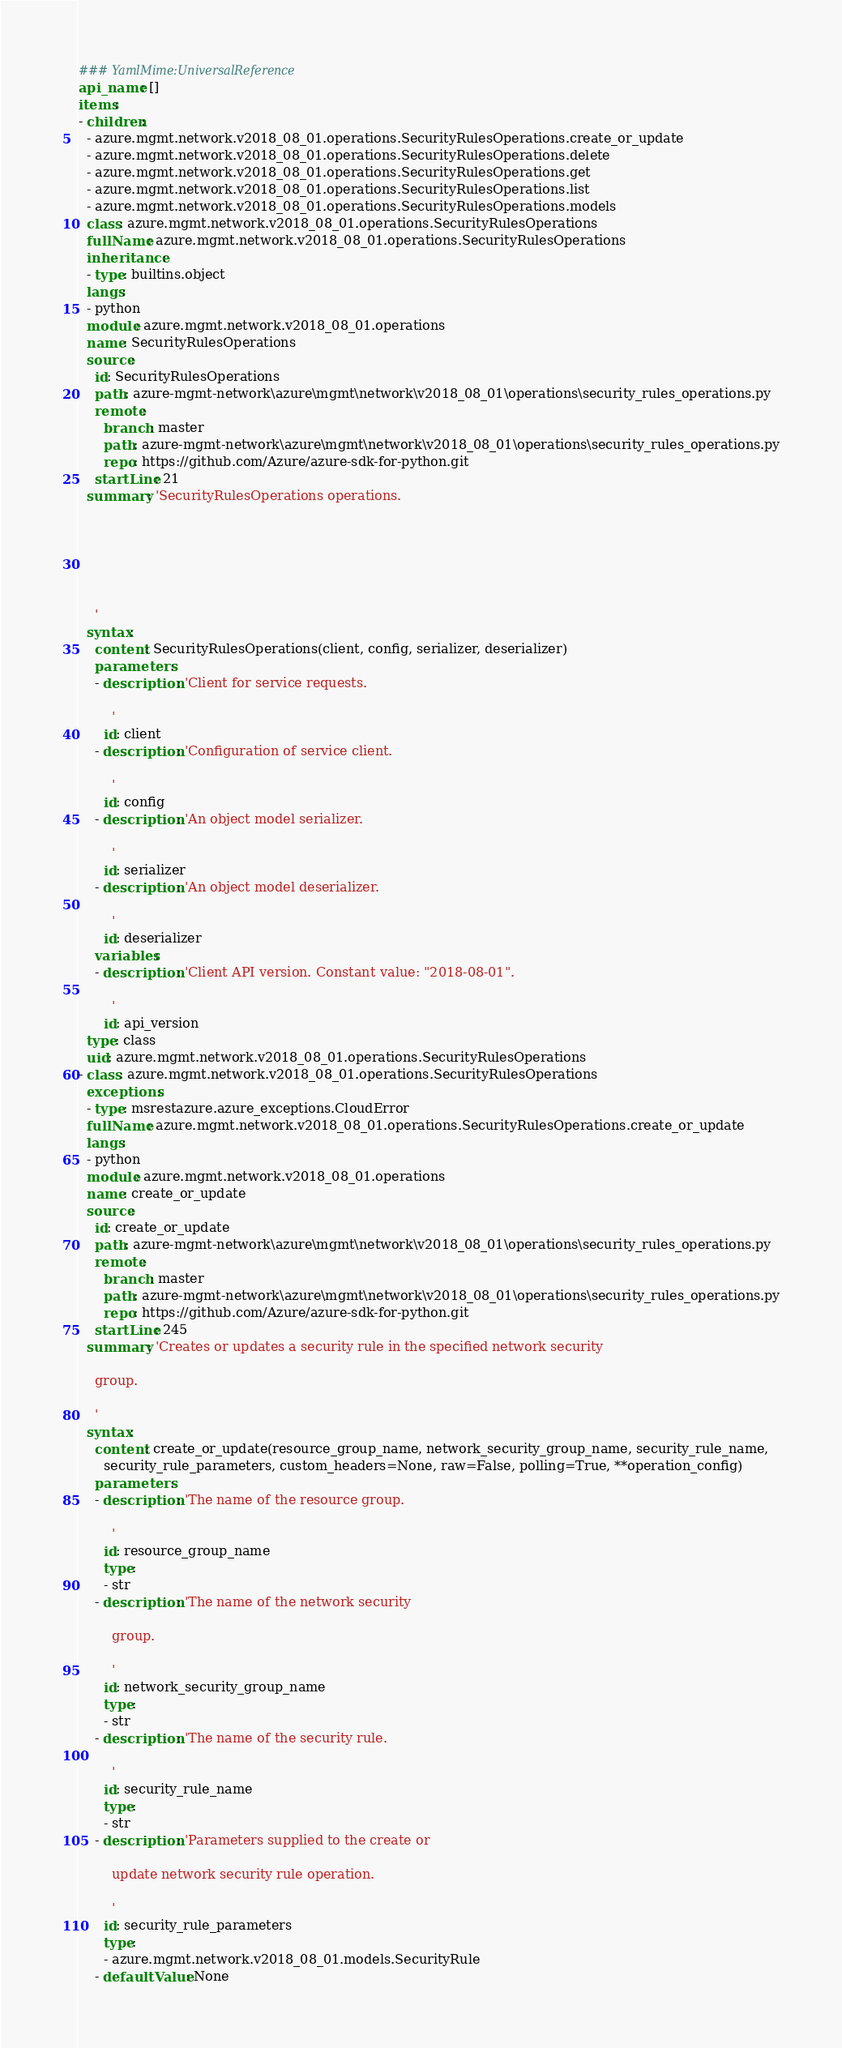<code> <loc_0><loc_0><loc_500><loc_500><_YAML_>### YamlMime:UniversalReference
api_name: []
items:
- children:
  - azure.mgmt.network.v2018_08_01.operations.SecurityRulesOperations.create_or_update
  - azure.mgmt.network.v2018_08_01.operations.SecurityRulesOperations.delete
  - azure.mgmt.network.v2018_08_01.operations.SecurityRulesOperations.get
  - azure.mgmt.network.v2018_08_01.operations.SecurityRulesOperations.list
  - azure.mgmt.network.v2018_08_01.operations.SecurityRulesOperations.models
  class: azure.mgmt.network.v2018_08_01.operations.SecurityRulesOperations
  fullName: azure.mgmt.network.v2018_08_01.operations.SecurityRulesOperations
  inheritance:
  - type: builtins.object
  langs:
  - python
  module: azure.mgmt.network.v2018_08_01.operations
  name: SecurityRulesOperations
  source:
    id: SecurityRulesOperations
    path: azure-mgmt-network\azure\mgmt\network\v2018_08_01\operations\security_rules_operations.py
    remote:
      branch: master
      path: azure-mgmt-network\azure\mgmt\network\v2018_08_01\operations\security_rules_operations.py
      repo: https://github.com/Azure/azure-sdk-for-python.git
    startLine: 21
  summary: 'SecurityRulesOperations operations.






    '
  syntax:
    content: SecurityRulesOperations(client, config, serializer, deserializer)
    parameters:
    - description: 'Client for service requests.

        '
      id: client
    - description: 'Configuration of service client.

        '
      id: config
    - description: 'An object model serializer.

        '
      id: serializer
    - description: 'An object model deserializer.

        '
      id: deserializer
    variables:
    - description: 'Client API version. Constant value: "2018-08-01".

        '
      id: api_version
  type: class
  uid: azure.mgmt.network.v2018_08_01.operations.SecurityRulesOperations
- class: azure.mgmt.network.v2018_08_01.operations.SecurityRulesOperations
  exceptions:
  - type: msrestazure.azure_exceptions.CloudError
  fullName: azure.mgmt.network.v2018_08_01.operations.SecurityRulesOperations.create_or_update
  langs:
  - python
  module: azure.mgmt.network.v2018_08_01.operations
  name: create_or_update
  source:
    id: create_or_update
    path: azure-mgmt-network\azure\mgmt\network\v2018_08_01\operations\security_rules_operations.py
    remote:
      branch: master
      path: azure-mgmt-network\azure\mgmt\network\v2018_08_01\operations\security_rules_operations.py
      repo: https://github.com/Azure/azure-sdk-for-python.git
    startLine: 245
  summary: 'Creates or updates a security rule in the specified network security

    group.

    '
  syntax:
    content: create_or_update(resource_group_name, network_security_group_name, security_rule_name,
      security_rule_parameters, custom_headers=None, raw=False, polling=True, **operation_config)
    parameters:
    - description: 'The name of the resource group.

        '
      id: resource_group_name
      type:
      - str
    - description: 'The name of the network security

        group.

        '
      id: network_security_group_name
      type:
      - str
    - description: 'The name of the security rule.

        '
      id: security_rule_name
      type:
      - str
    - description: 'Parameters supplied to the create or

        update network security rule operation.

        '
      id: security_rule_parameters
      type:
      - azure.mgmt.network.v2018_08_01.models.SecurityRule
    - defaultValue: None</code> 